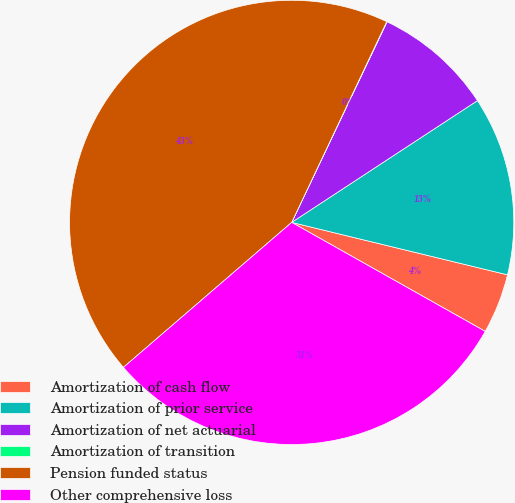Convert chart to OTSL. <chart><loc_0><loc_0><loc_500><loc_500><pie_chart><fcel>Amortization of cash flow<fcel>Amortization of prior service<fcel>Amortization of net actuarial<fcel>Amortization of transition<fcel>Pension funded status<fcel>Other comprehensive loss<nl><fcel>4.37%<fcel>13.03%<fcel>8.7%<fcel>0.03%<fcel>43.36%<fcel>30.52%<nl></chart> 